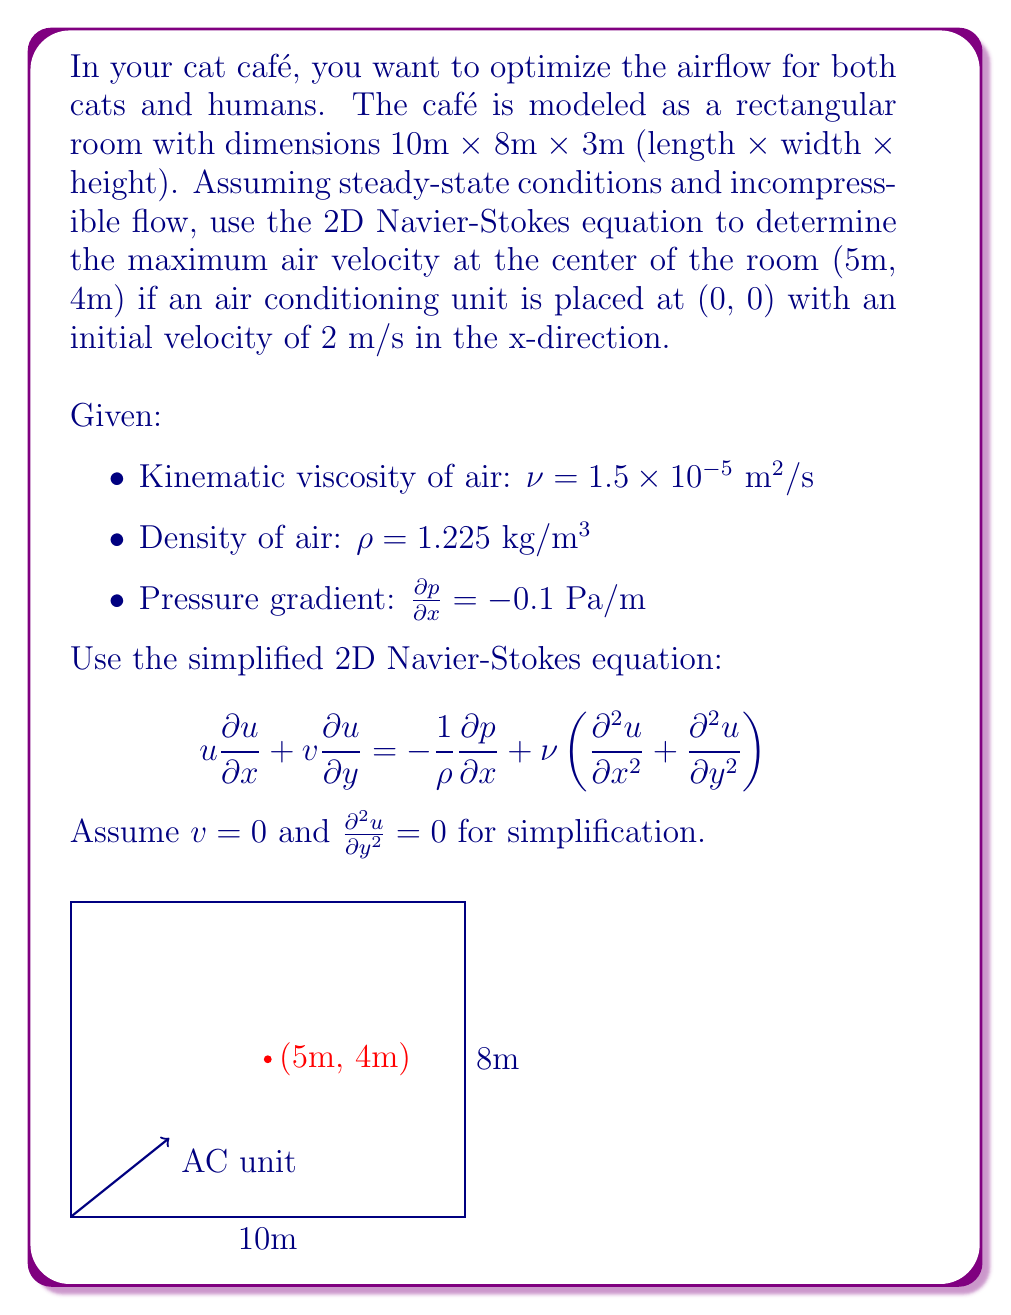What is the answer to this math problem? Let's approach this step-by-step:

1) Given the simplifications, our Navier-Stokes equation becomes:

   $$u \frac{\partial u}{\partial x} = -\frac{1}{\rho}\frac{\partial p}{\partial x} + \nu \frac{\partial^2 u}{\partial x^2}$$

2) We can assume that $\frac{\partial^2 u}{\partial x^2}$ is constant for this simplified model. Let's call it $k$. So:

   $$u \frac{\partial u}{\partial x} = -\frac{1}{\rho}\frac{\partial p}{\partial x} + \nu k$$

3) Substituting the given values:

   $$u \frac{\partial u}{\partial x} = -\frac{1}{1.225}(-0.1) + 1.5 \times 10^{-5} k$$

4) Simplify:

   $$u \frac{\partial u}{\partial x} = 0.0816 + 1.5 \times 10^{-5} k$$

5) We can integrate this with respect to x:

   $$\int u \frac{\partial u}{\partial x} dx = \int (0.0816 + 1.5 \times 10^{-5} k) dx$$

6) This gives us:

   $$\frac{1}{2}u^2 = 0.0816x + 1.5 \times 10^{-5} kx + C$$

7) At x = 0, u = 2 m/s (initial velocity), so:

   $$2 = C$$

8) At the center (x = 5m), we can write:

   $$\frac{1}{2}u^2 = 0.0816 \cdot 5 + 1.5 \times 10^{-5} k \cdot 5 + 2$$

9) Simplify:

   $$\frac{1}{2}u^2 = 0.408 + 7.5 \times 10^{-5} k + 2$$

10) To maximize u, we need to maximize k. The maximum reasonable value for k would be when the velocity reaches its peak at the center. This occurs when $\frac{\partial u}{\partial x} = 0$ at x = 5m.

11) From step 4, setting $\frac{\partial u}{\partial x} = 0$:

    $$0 = 0.0816 + 1.5 \times 10^{-5} k$$

12) Solve for k:

    $$k = -\frac{0.0816}{1.5 \times 10^{-5}} = -5440$$

13) Substitute this back into the equation from step 9:

    $$\frac{1}{2}u^2 = 0.408 + 7.5 \times 10^{-5} (-5440) + 2$$
    $$\frac{1}{2}u^2 = 2$$

14) Solve for u:

    $$u = \sqrt{4} = 2 \text{ m/s}$$

Therefore, the maximum air velocity at the center of the room is 2 m/s.
Answer: 2 m/s 